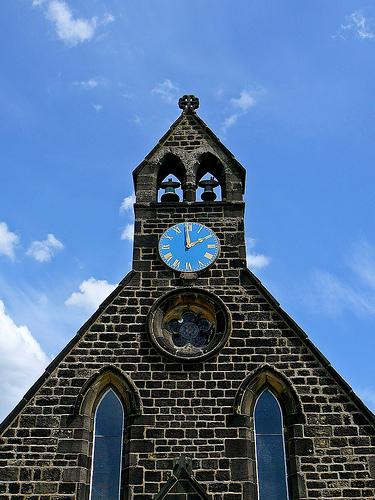Question: how many bells are in this picture?
Choices:
A. Two.
B. One.
C. Three.
D. Four.
Answer with the letter. Answer: A Question: when in the day was the picture taken?
Choices:
A. Two O'Clock.
B. Sunrise.
C. Dawn.
D. Midnight.
Answer with the letter. Answer: A Question: what shape is the window under the clock?
Choices:
A. An octagon.
B. A circle.
C. A square.
D. A diamond.
Answer with the letter. Answer: B Question: what material is the building made of?
Choices:
A. Concrete.
B. Redwood.
C. Aluminum.
D. Brick.
Answer with the letter. Answer: D Question: how can we tell the time in the picture?
Choices:
A. It's sunny.
B. The timestamp.
C. The store in the background is open.
D. From the clock.
Answer with the letter. Answer: D Question: what shape are the tops of the windows at the bottom of the picture?
Choices:
A. Square.
B. Arches.
C. Round.
D. Oval.
Answer with the letter. Answer: B Question: when will it be three o'clock in this picture?
Choices:
A. In five minutes.
B. In ten hours.
C. In an hour.
D. In two seconds.
Answer with the letter. Answer: C 